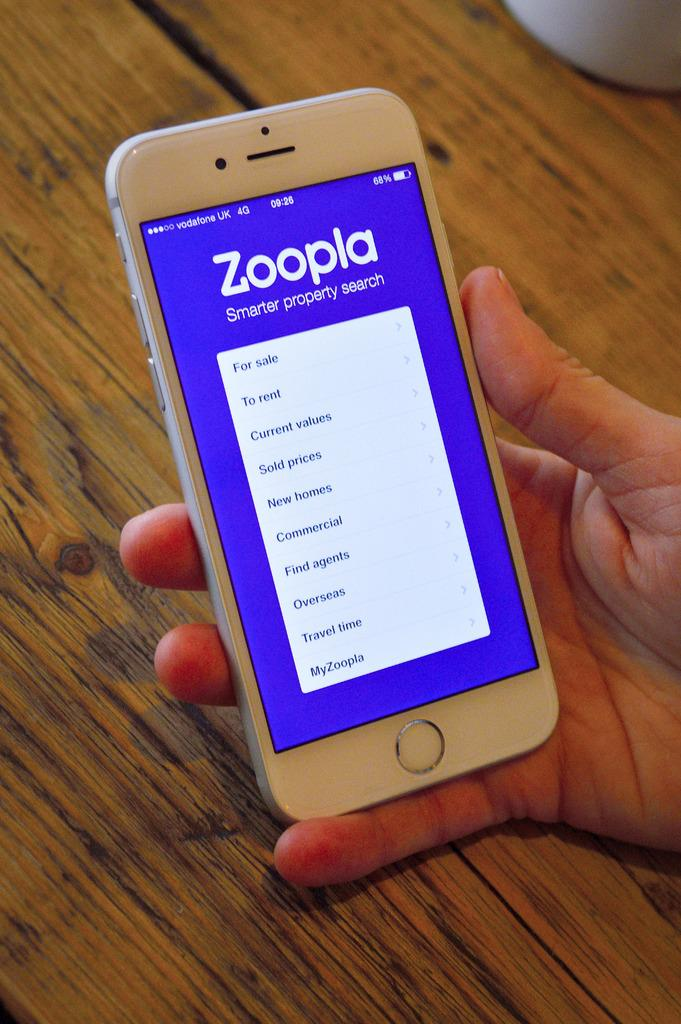<image>
Give a short and clear explanation of the subsequent image. white ippne is turned on and opened app of zoopla 